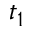<formula> <loc_0><loc_0><loc_500><loc_500>t _ { 1 }</formula> 